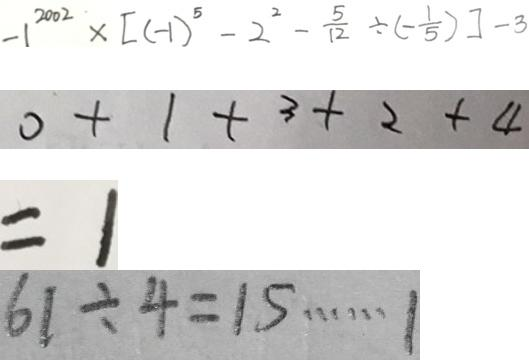Convert formula to latex. <formula><loc_0><loc_0><loc_500><loc_500>- 1 ^ { 2 0 0 2 } \times [ ( - 1 ) ^ { 5 } - 2 ^ { 2 } - \frac { 5 } { 1 2 } \div ( - \frac { 1 } { 5 } ) ] - 3 
 0 + 1 + 3 + 2 + 4 
 = 1 
 6 1 \div 4 = 1 5 \cdots 1</formula> 